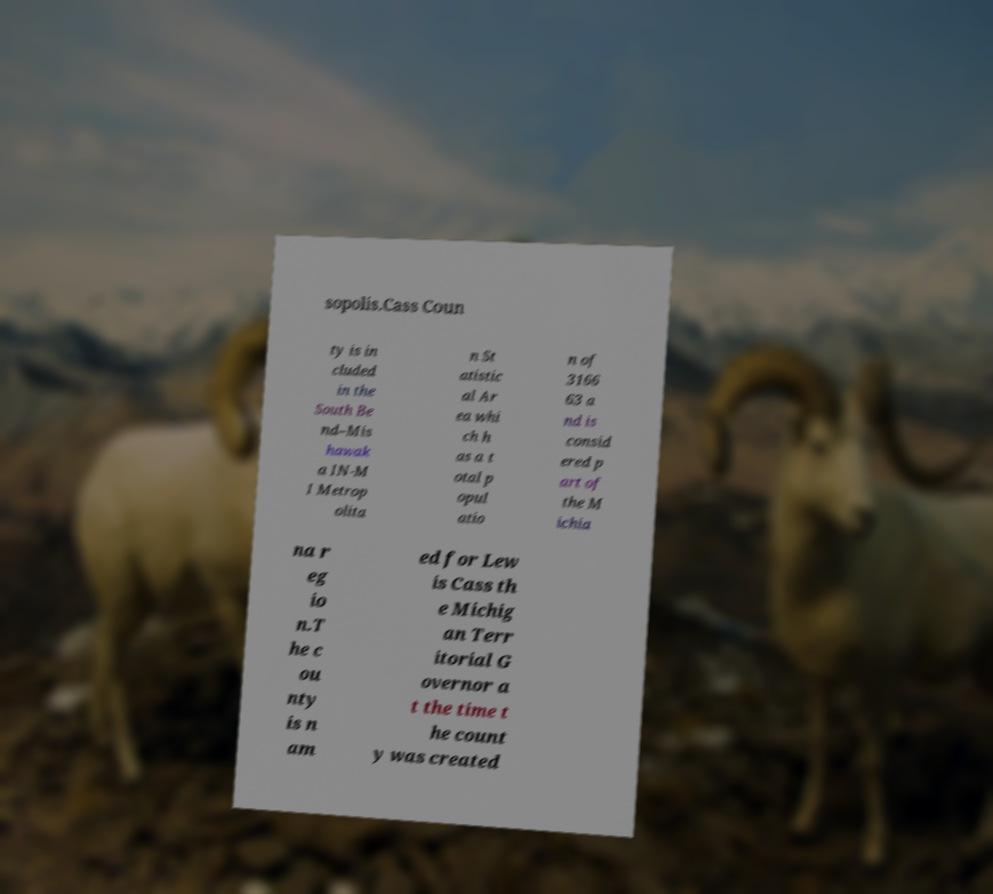Could you assist in decoding the text presented in this image and type it out clearly? sopolis.Cass Coun ty is in cluded in the South Be nd–Mis hawak a IN-M I Metrop olita n St atistic al Ar ea whi ch h as a t otal p opul atio n of 3166 63 a nd is consid ered p art of the M ichia na r eg io n.T he c ou nty is n am ed for Lew is Cass th e Michig an Terr itorial G overnor a t the time t he count y was created 